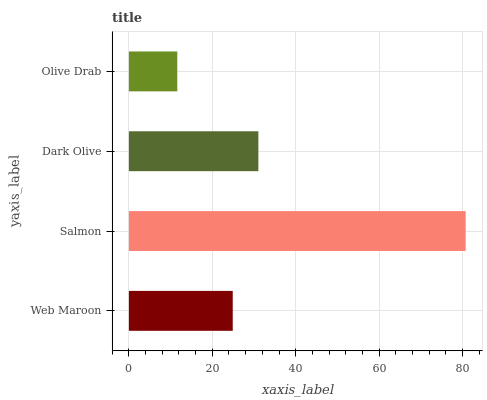Is Olive Drab the minimum?
Answer yes or no. Yes. Is Salmon the maximum?
Answer yes or no. Yes. Is Dark Olive the minimum?
Answer yes or no. No. Is Dark Olive the maximum?
Answer yes or no. No. Is Salmon greater than Dark Olive?
Answer yes or no. Yes. Is Dark Olive less than Salmon?
Answer yes or no. Yes. Is Dark Olive greater than Salmon?
Answer yes or no. No. Is Salmon less than Dark Olive?
Answer yes or no. No. Is Dark Olive the high median?
Answer yes or no. Yes. Is Web Maroon the low median?
Answer yes or no. Yes. Is Olive Drab the high median?
Answer yes or no. No. Is Salmon the low median?
Answer yes or no. No. 